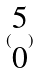Convert formula to latex. <formula><loc_0><loc_0><loc_500><loc_500>( \begin{matrix} 5 \\ 0 \end{matrix} )</formula> 